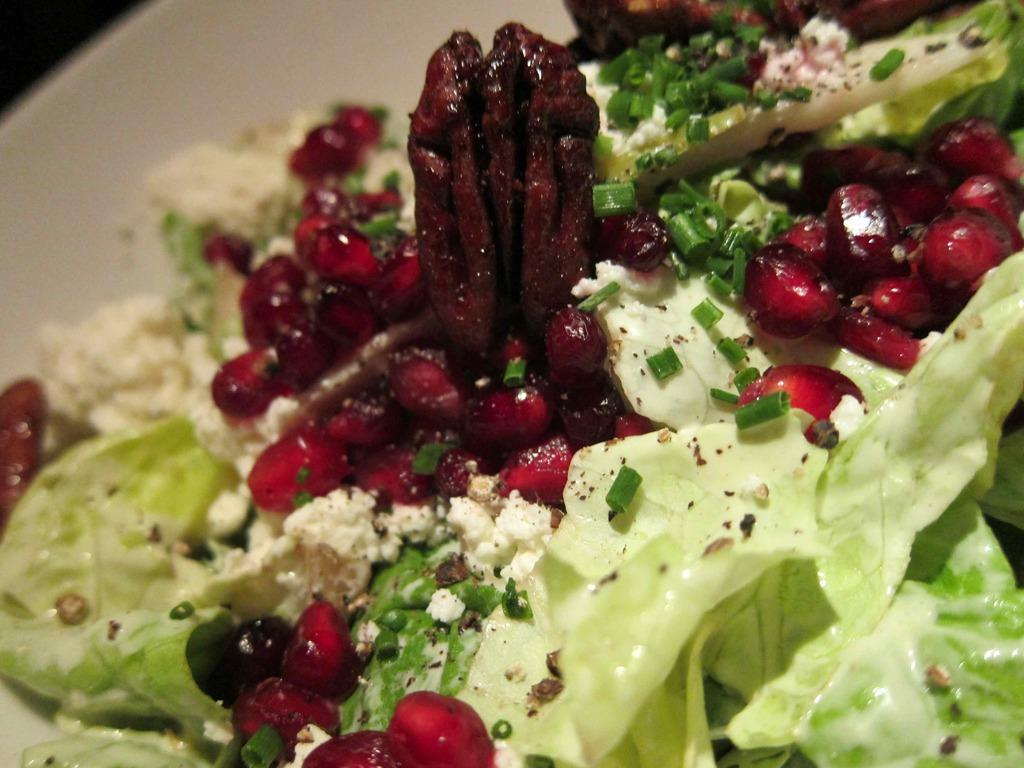What color is the plate that contains the food in the image? The plate is white. What type of food can be seen in the plate? Cabbage and pomegranate are present in the plate. How many stitches are visible on the pomegranate in the image? There are no stitches visible on the pomegranate in the image, as it is a fruit and not a piece of fabric. 